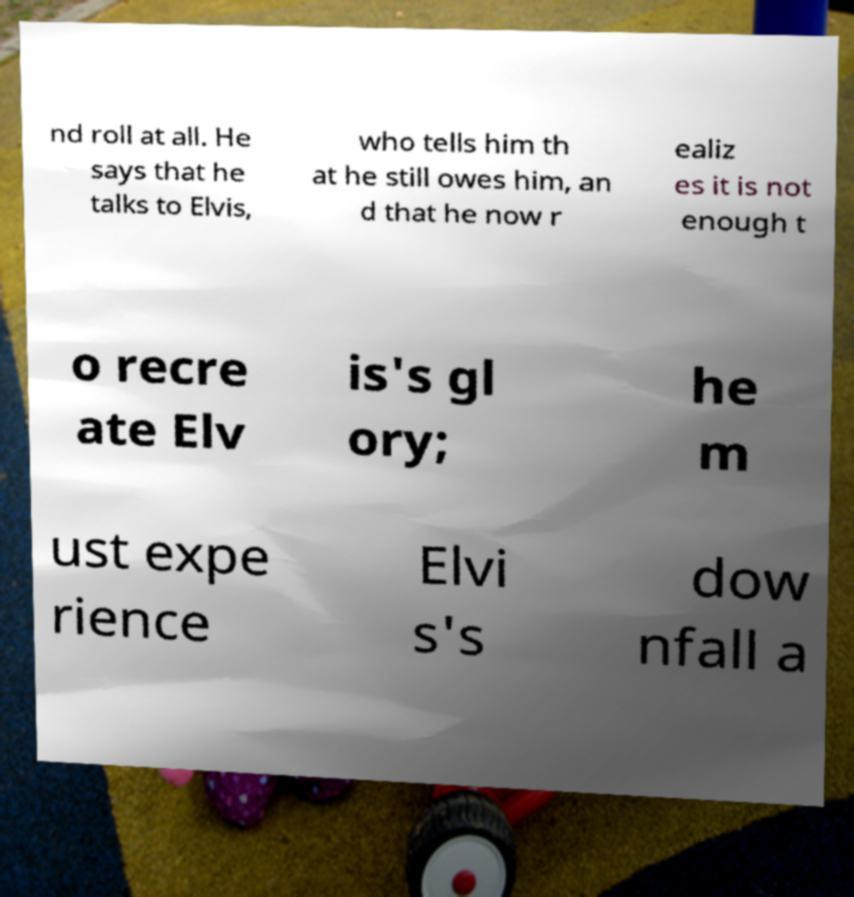Please identify and transcribe the text found in this image. nd roll at all. He says that he talks to Elvis, who tells him th at he still owes him, an d that he now r ealiz es it is not enough t o recre ate Elv is's gl ory; he m ust expe rience Elvi s's dow nfall a 